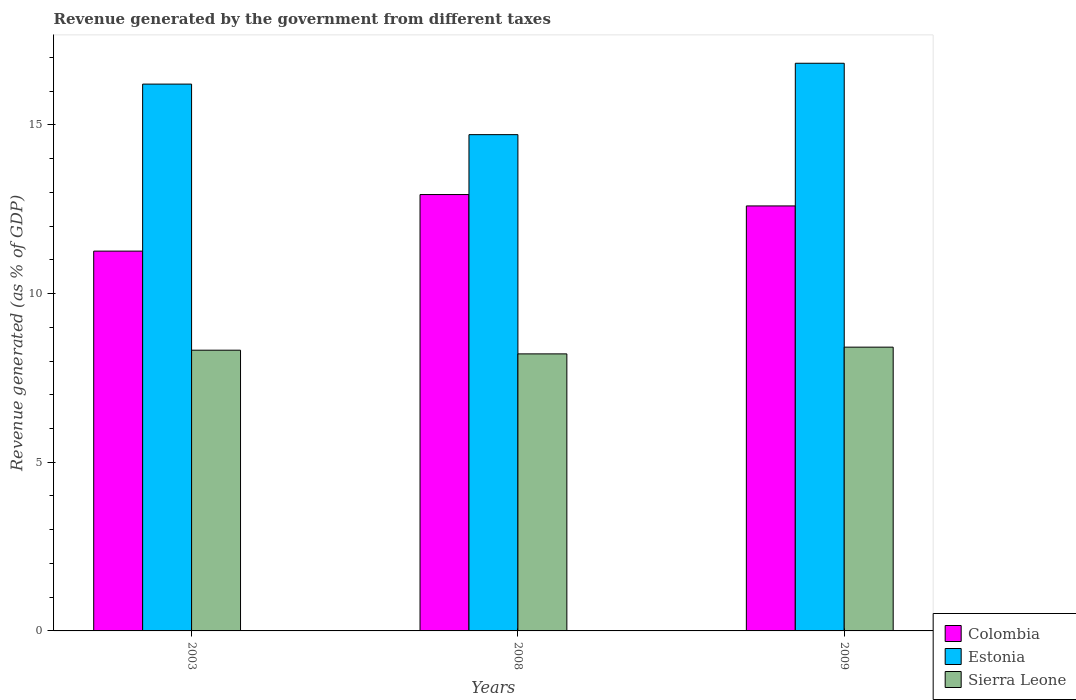Are the number of bars per tick equal to the number of legend labels?
Your response must be concise. Yes. What is the label of the 3rd group of bars from the left?
Keep it short and to the point. 2009. In how many cases, is the number of bars for a given year not equal to the number of legend labels?
Provide a short and direct response. 0. What is the revenue generated by the government in Estonia in 2009?
Offer a very short reply. 16.83. Across all years, what is the maximum revenue generated by the government in Sierra Leone?
Offer a terse response. 8.41. Across all years, what is the minimum revenue generated by the government in Sierra Leone?
Offer a terse response. 8.21. In which year was the revenue generated by the government in Sierra Leone maximum?
Offer a terse response. 2009. What is the total revenue generated by the government in Estonia in the graph?
Your answer should be compact. 47.75. What is the difference between the revenue generated by the government in Estonia in 2008 and that in 2009?
Make the answer very short. -2.12. What is the difference between the revenue generated by the government in Sierra Leone in 2008 and the revenue generated by the government in Estonia in 2009?
Provide a succinct answer. -8.62. What is the average revenue generated by the government in Colombia per year?
Offer a very short reply. 12.26. In the year 2009, what is the difference between the revenue generated by the government in Sierra Leone and revenue generated by the government in Colombia?
Keep it short and to the point. -4.19. In how many years, is the revenue generated by the government in Sierra Leone greater than 11 %?
Offer a very short reply. 0. What is the ratio of the revenue generated by the government in Estonia in 2003 to that in 2009?
Give a very brief answer. 0.96. Is the difference between the revenue generated by the government in Sierra Leone in 2008 and 2009 greater than the difference between the revenue generated by the government in Colombia in 2008 and 2009?
Make the answer very short. No. What is the difference between the highest and the second highest revenue generated by the government in Colombia?
Provide a succinct answer. 0.34. What is the difference between the highest and the lowest revenue generated by the government in Colombia?
Ensure brevity in your answer.  1.68. In how many years, is the revenue generated by the government in Estonia greater than the average revenue generated by the government in Estonia taken over all years?
Ensure brevity in your answer.  2. Is the sum of the revenue generated by the government in Sierra Leone in 2003 and 2009 greater than the maximum revenue generated by the government in Estonia across all years?
Your response must be concise. No. What does the 2nd bar from the left in 2003 represents?
Your answer should be compact. Estonia. What does the 1st bar from the right in 2009 represents?
Give a very brief answer. Sierra Leone. Is it the case that in every year, the sum of the revenue generated by the government in Estonia and revenue generated by the government in Sierra Leone is greater than the revenue generated by the government in Colombia?
Your answer should be compact. Yes. How many bars are there?
Keep it short and to the point. 9. What is the difference between two consecutive major ticks on the Y-axis?
Offer a terse response. 5. Are the values on the major ticks of Y-axis written in scientific E-notation?
Provide a succinct answer. No. How many legend labels are there?
Make the answer very short. 3. How are the legend labels stacked?
Your answer should be compact. Vertical. What is the title of the graph?
Offer a very short reply. Revenue generated by the government from different taxes. Does "Ukraine" appear as one of the legend labels in the graph?
Your answer should be very brief. No. What is the label or title of the Y-axis?
Your response must be concise. Revenue generated (as % of GDP). What is the Revenue generated (as % of GDP) in Colombia in 2003?
Your answer should be very brief. 11.26. What is the Revenue generated (as % of GDP) in Estonia in 2003?
Ensure brevity in your answer.  16.21. What is the Revenue generated (as % of GDP) of Sierra Leone in 2003?
Offer a terse response. 8.32. What is the Revenue generated (as % of GDP) in Colombia in 2008?
Offer a terse response. 12.94. What is the Revenue generated (as % of GDP) in Estonia in 2008?
Provide a short and direct response. 14.71. What is the Revenue generated (as % of GDP) in Sierra Leone in 2008?
Give a very brief answer. 8.21. What is the Revenue generated (as % of GDP) of Colombia in 2009?
Offer a terse response. 12.6. What is the Revenue generated (as % of GDP) of Estonia in 2009?
Your answer should be compact. 16.83. What is the Revenue generated (as % of GDP) of Sierra Leone in 2009?
Your answer should be compact. 8.41. Across all years, what is the maximum Revenue generated (as % of GDP) of Colombia?
Offer a terse response. 12.94. Across all years, what is the maximum Revenue generated (as % of GDP) in Estonia?
Ensure brevity in your answer.  16.83. Across all years, what is the maximum Revenue generated (as % of GDP) of Sierra Leone?
Provide a short and direct response. 8.41. Across all years, what is the minimum Revenue generated (as % of GDP) of Colombia?
Keep it short and to the point. 11.26. Across all years, what is the minimum Revenue generated (as % of GDP) of Estonia?
Give a very brief answer. 14.71. Across all years, what is the minimum Revenue generated (as % of GDP) of Sierra Leone?
Provide a succinct answer. 8.21. What is the total Revenue generated (as % of GDP) in Colombia in the graph?
Make the answer very short. 36.79. What is the total Revenue generated (as % of GDP) in Estonia in the graph?
Provide a short and direct response. 47.75. What is the total Revenue generated (as % of GDP) in Sierra Leone in the graph?
Your response must be concise. 24.95. What is the difference between the Revenue generated (as % of GDP) in Colombia in 2003 and that in 2008?
Your answer should be compact. -1.68. What is the difference between the Revenue generated (as % of GDP) in Estonia in 2003 and that in 2008?
Make the answer very short. 1.5. What is the difference between the Revenue generated (as % of GDP) of Sierra Leone in 2003 and that in 2008?
Your answer should be compact. 0.11. What is the difference between the Revenue generated (as % of GDP) of Colombia in 2003 and that in 2009?
Keep it short and to the point. -1.34. What is the difference between the Revenue generated (as % of GDP) in Estonia in 2003 and that in 2009?
Keep it short and to the point. -0.62. What is the difference between the Revenue generated (as % of GDP) in Sierra Leone in 2003 and that in 2009?
Make the answer very short. -0.09. What is the difference between the Revenue generated (as % of GDP) in Colombia in 2008 and that in 2009?
Make the answer very short. 0.34. What is the difference between the Revenue generated (as % of GDP) in Estonia in 2008 and that in 2009?
Provide a succinct answer. -2.12. What is the difference between the Revenue generated (as % of GDP) of Sierra Leone in 2008 and that in 2009?
Provide a short and direct response. -0.2. What is the difference between the Revenue generated (as % of GDP) of Colombia in 2003 and the Revenue generated (as % of GDP) of Estonia in 2008?
Give a very brief answer. -3.45. What is the difference between the Revenue generated (as % of GDP) of Colombia in 2003 and the Revenue generated (as % of GDP) of Sierra Leone in 2008?
Make the answer very short. 3.05. What is the difference between the Revenue generated (as % of GDP) in Estonia in 2003 and the Revenue generated (as % of GDP) in Sierra Leone in 2008?
Offer a terse response. 8. What is the difference between the Revenue generated (as % of GDP) in Colombia in 2003 and the Revenue generated (as % of GDP) in Estonia in 2009?
Ensure brevity in your answer.  -5.57. What is the difference between the Revenue generated (as % of GDP) in Colombia in 2003 and the Revenue generated (as % of GDP) in Sierra Leone in 2009?
Provide a succinct answer. 2.85. What is the difference between the Revenue generated (as % of GDP) of Estonia in 2003 and the Revenue generated (as % of GDP) of Sierra Leone in 2009?
Your response must be concise. 7.8. What is the difference between the Revenue generated (as % of GDP) in Colombia in 2008 and the Revenue generated (as % of GDP) in Estonia in 2009?
Make the answer very short. -3.89. What is the difference between the Revenue generated (as % of GDP) in Colombia in 2008 and the Revenue generated (as % of GDP) in Sierra Leone in 2009?
Give a very brief answer. 4.52. What is the difference between the Revenue generated (as % of GDP) of Estonia in 2008 and the Revenue generated (as % of GDP) of Sierra Leone in 2009?
Give a very brief answer. 6.3. What is the average Revenue generated (as % of GDP) in Colombia per year?
Offer a terse response. 12.26. What is the average Revenue generated (as % of GDP) in Estonia per year?
Offer a very short reply. 15.92. What is the average Revenue generated (as % of GDP) in Sierra Leone per year?
Your answer should be very brief. 8.32. In the year 2003, what is the difference between the Revenue generated (as % of GDP) in Colombia and Revenue generated (as % of GDP) in Estonia?
Offer a terse response. -4.95. In the year 2003, what is the difference between the Revenue generated (as % of GDP) in Colombia and Revenue generated (as % of GDP) in Sierra Leone?
Provide a short and direct response. 2.94. In the year 2003, what is the difference between the Revenue generated (as % of GDP) in Estonia and Revenue generated (as % of GDP) in Sierra Leone?
Provide a short and direct response. 7.89. In the year 2008, what is the difference between the Revenue generated (as % of GDP) in Colombia and Revenue generated (as % of GDP) in Estonia?
Your answer should be very brief. -1.78. In the year 2008, what is the difference between the Revenue generated (as % of GDP) in Colombia and Revenue generated (as % of GDP) in Sierra Leone?
Provide a succinct answer. 4.72. In the year 2008, what is the difference between the Revenue generated (as % of GDP) in Estonia and Revenue generated (as % of GDP) in Sierra Leone?
Make the answer very short. 6.5. In the year 2009, what is the difference between the Revenue generated (as % of GDP) in Colombia and Revenue generated (as % of GDP) in Estonia?
Keep it short and to the point. -4.23. In the year 2009, what is the difference between the Revenue generated (as % of GDP) of Colombia and Revenue generated (as % of GDP) of Sierra Leone?
Ensure brevity in your answer.  4.19. In the year 2009, what is the difference between the Revenue generated (as % of GDP) of Estonia and Revenue generated (as % of GDP) of Sierra Leone?
Your answer should be very brief. 8.42. What is the ratio of the Revenue generated (as % of GDP) in Colombia in 2003 to that in 2008?
Provide a short and direct response. 0.87. What is the ratio of the Revenue generated (as % of GDP) of Estonia in 2003 to that in 2008?
Your response must be concise. 1.1. What is the ratio of the Revenue generated (as % of GDP) in Sierra Leone in 2003 to that in 2008?
Offer a terse response. 1.01. What is the ratio of the Revenue generated (as % of GDP) of Colombia in 2003 to that in 2009?
Provide a succinct answer. 0.89. What is the ratio of the Revenue generated (as % of GDP) of Estonia in 2003 to that in 2009?
Your response must be concise. 0.96. What is the ratio of the Revenue generated (as % of GDP) in Sierra Leone in 2003 to that in 2009?
Give a very brief answer. 0.99. What is the ratio of the Revenue generated (as % of GDP) of Colombia in 2008 to that in 2009?
Make the answer very short. 1.03. What is the ratio of the Revenue generated (as % of GDP) of Estonia in 2008 to that in 2009?
Keep it short and to the point. 0.87. What is the ratio of the Revenue generated (as % of GDP) in Sierra Leone in 2008 to that in 2009?
Offer a terse response. 0.98. What is the difference between the highest and the second highest Revenue generated (as % of GDP) of Colombia?
Offer a very short reply. 0.34. What is the difference between the highest and the second highest Revenue generated (as % of GDP) of Estonia?
Provide a short and direct response. 0.62. What is the difference between the highest and the second highest Revenue generated (as % of GDP) of Sierra Leone?
Give a very brief answer. 0.09. What is the difference between the highest and the lowest Revenue generated (as % of GDP) in Colombia?
Your answer should be compact. 1.68. What is the difference between the highest and the lowest Revenue generated (as % of GDP) in Estonia?
Your response must be concise. 2.12. What is the difference between the highest and the lowest Revenue generated (as % of GDP) in Sierra Leone?
Offer a very short reply. 0.2. 